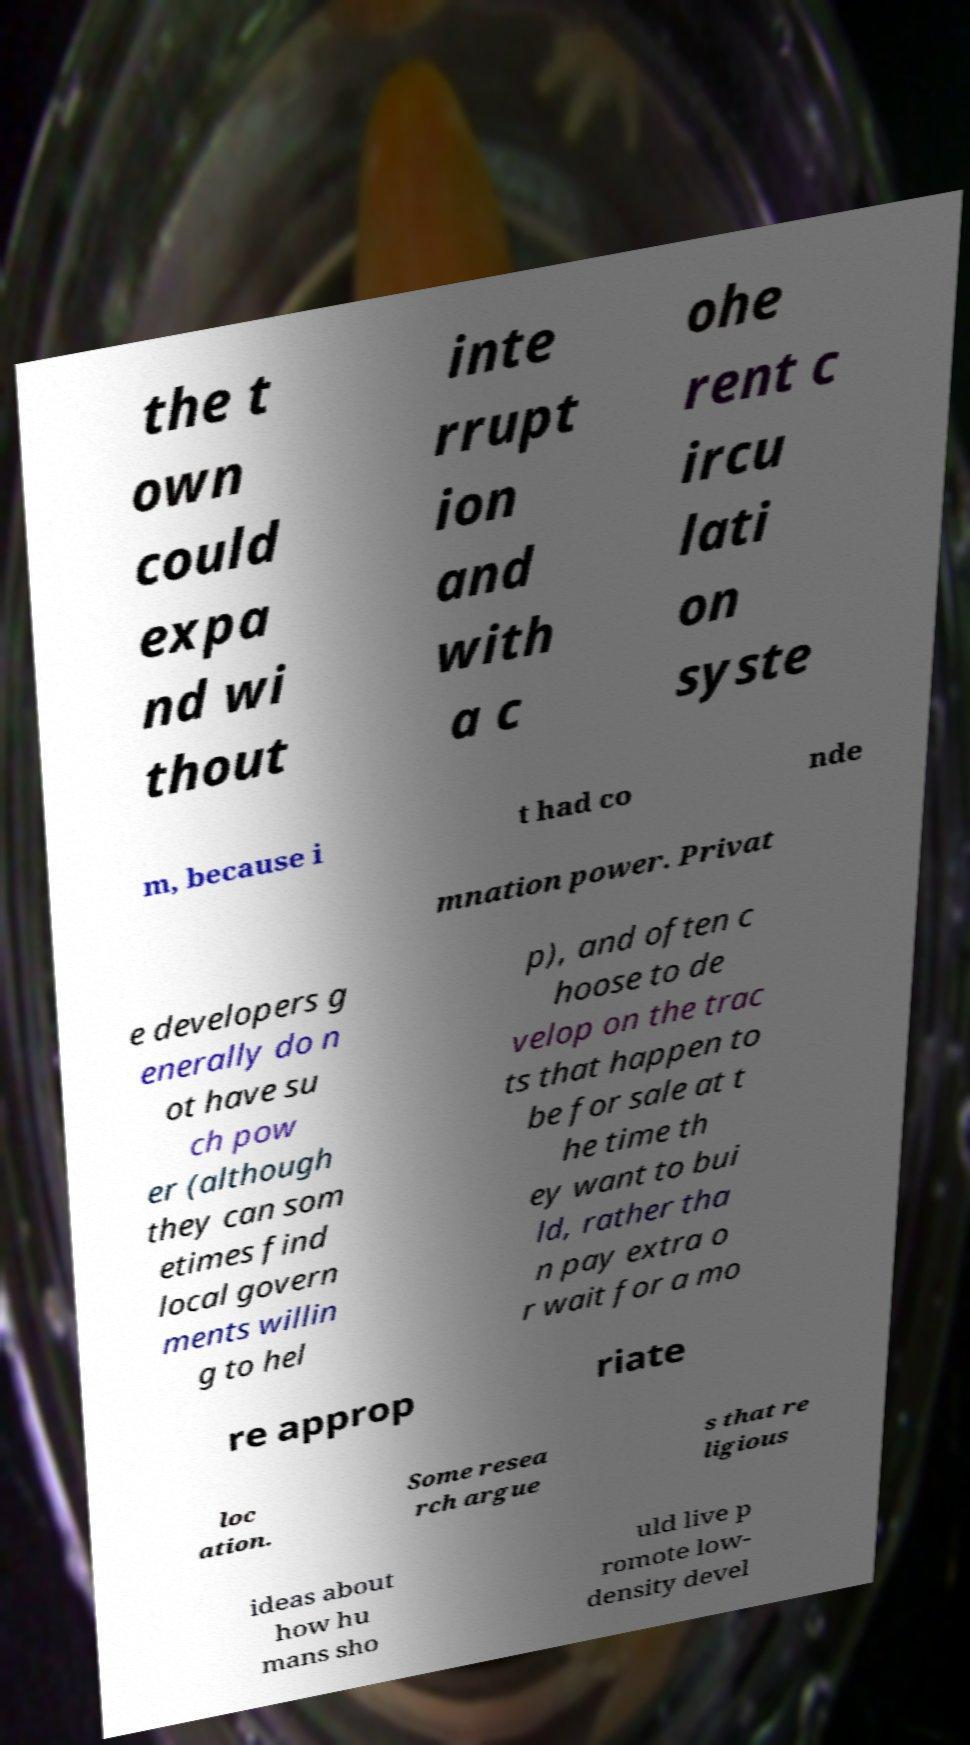Please read and relay the text visible in this image. What does it say? the t own could expa nd wi thout inte rrupt ion and with a c ohe rent c ircu lati on syste m, because i t had co nde mnation power. Privat e developers g enerally do n ot have su ch pow er (although they can som etimes find local govern ments willin g to hel p), and often c hoose to de velop on the trac ts that happen to be for sale at t he time th ey want to bui ld, rather tha n pay extra o r wait for a mo re approp riate loc ation. Some resea rch argue s that re ligious ideas about how hu mans sho uld live p romote low- density devel 